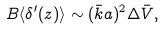Convert formula to latex. <formula><loc_0><loc_0><loc_500><loc_500>B \langle \delta ^ { \prime } ( z ) \rangle \sim ( \bar { k } a ) ^ { 2 } \Delta \bar { V } ,</formula> 